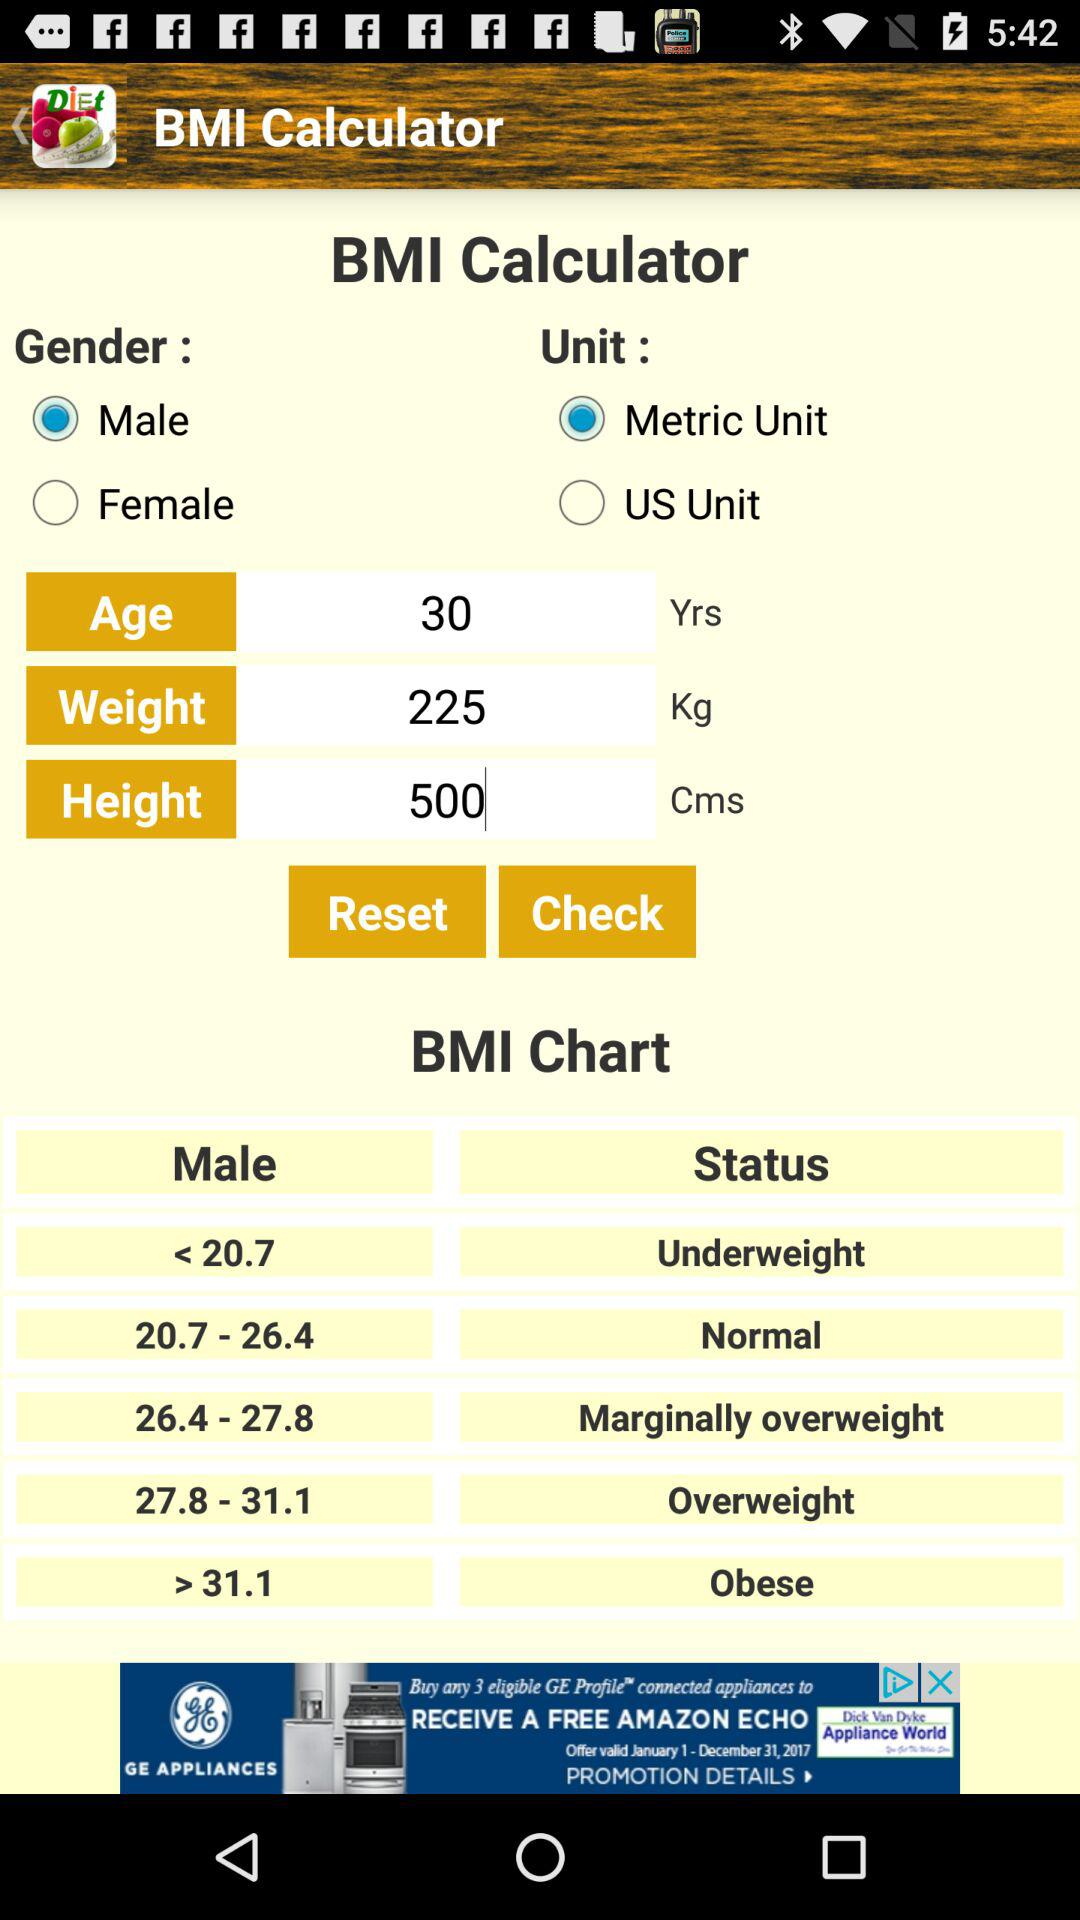What is the age? The age is 30 years. 